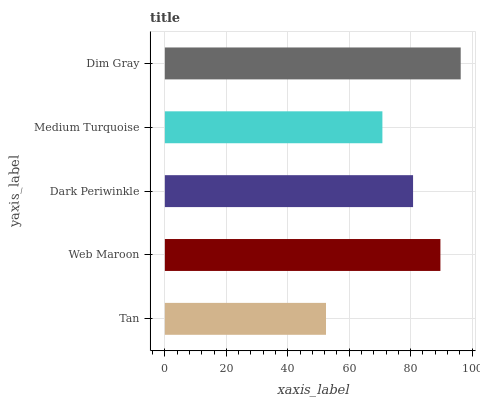Is Tan the minimum?
Answer yes or no. Yes. Is Dim Gray the maximum?
Answer yes or no. Yes. Is Web Maroon the minimum?
Answer yes or no. No. Is Web Maroon the maximum?
Answer yes or no. No. Is Web Maroon greater than Tan?
Answer yes or no. Yes. Is Tan less than Web Maroon?
Answer yes or no. Yes. Is Tan greater than Web Maroon?
Answer yes or no. No. Is Web Maroon less than Tan?
Answer yes or no. No. Is Dark Periwinkle the high median?
Answer yes or no. Yes. Is Dark Periwinkle the low median?
Answer yes or no. Yes. Is Dim Gray the high median?
Answer yes or no. No. Is Dim Gray the low median?
Answer yes or no. No. 